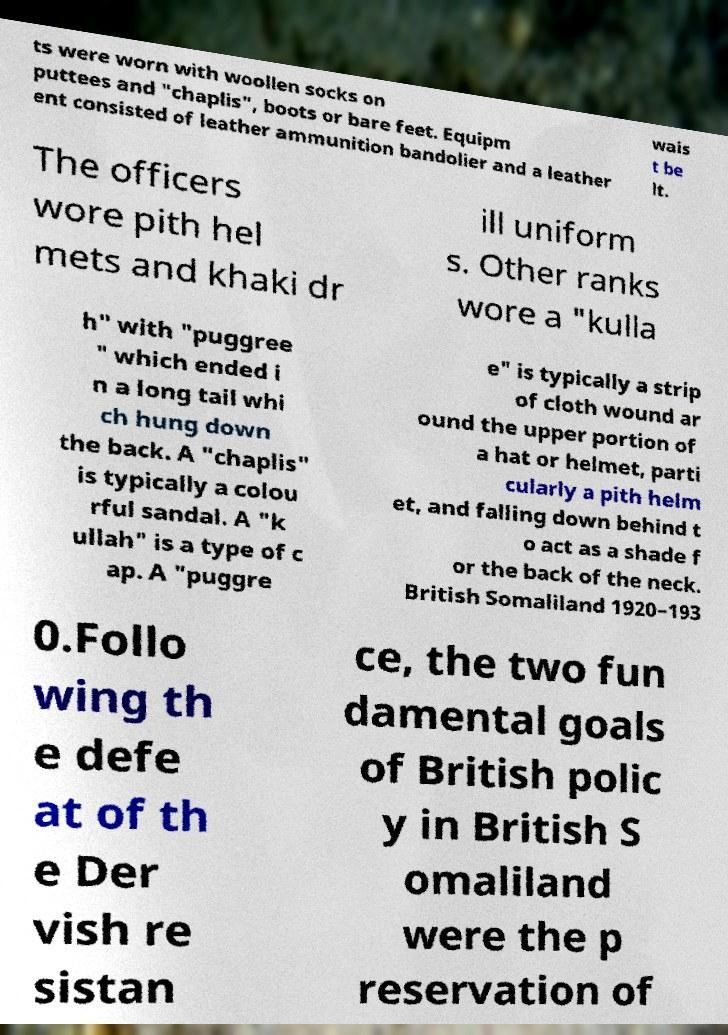Please read and relay the text visible in this image. What does it say? ts were worn with woollen socks on puttees and "chaplis", boots or bare feet. Equipm ent consisted of leather ammunition bandolier and a leather wais t be lt. The officers wore pith hel mets and khaki dr ill uniform s. Other ranks wore a "kulla h" with "puggree " which ended i n a long tail whi ch hung down the back. A "chaplis" is typically a colou rful sandal. A "k ullah" is a type of c ap. A "puggre e" is typically a strip of cloth wound ar ound the upper portion of a hat or helmet, parti cularly a pith helm et, and falling down behind t o act as a shade f or the back of the neck. British Somaliland 1920–193 0.Follo wing th e defe at of th e Der vish re sistan ce, the two fun damental goals of British polic y in British S omaliland were the p reservation of 